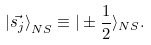<formula> <loc_0><loc_0><loc_500><loc_500>{ | \vec { s _ { j } } \rangle } _ { N S } \equiv | \pm \frac { 1 } { 2 } \rangle _ { N S } .</formula> 